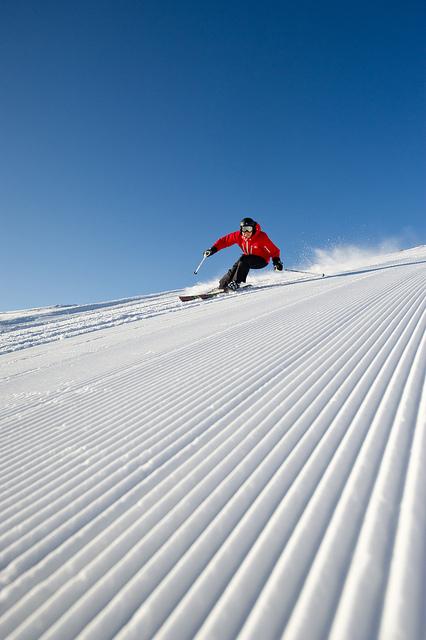Is this a dangerous sport?
Write a very short answer. Yes. What color coat is he wearing?
Keep it brief. Red. Is this photo taken in the summer?
Concise answer only. No. 